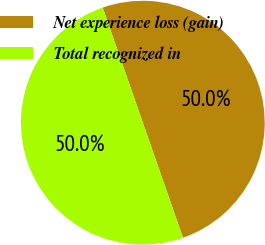<chart> <loc_0><loc_0><loc_500><loc_500><pie_chart><fcel>Net experience loss (gain)<fcel>Total recognized in<nl><fcel>50.0%<fcel>50.0%<nl></chart> 